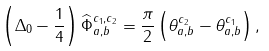Convert formula to latex. <formula><loc_0><loc_0><loc_500><loc_500>\left ( \Delta _ { 0 } - \frac { 1 } { 4 } \right ) \widehat { \Phi } _ { a , b } ^ { c _ { 1 } , c _ { 2 } } = \frac { \pi } { 2 } \left ( \theta _ { a , b } ^ { c _ { 2 } } - \theta _ { a , b } ^ { c _ { 1 } } \right ) ,</formula> 